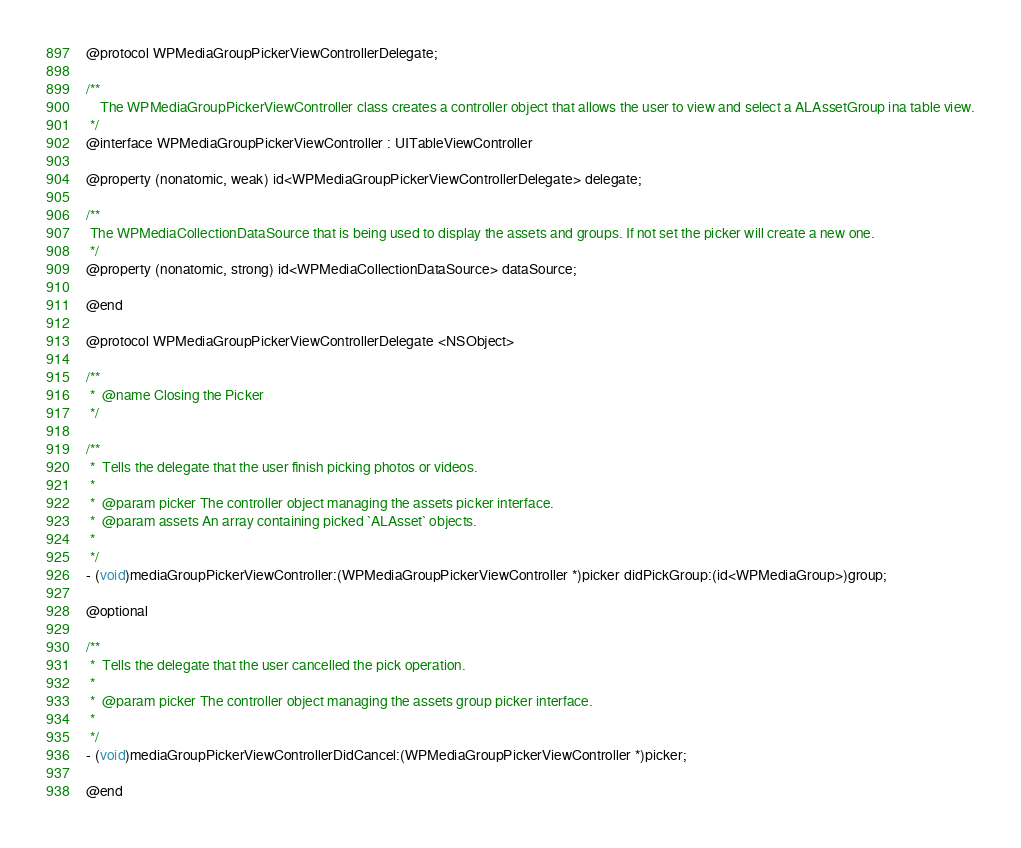<code> <loc_0><loc_0><loc_500><loc_500><_C_>
@protocol WPMediaGroupPickerViewControllerDelegate;

/**
    The WPMediaGroupPickerViewController class creates a controller object that allows the user to view and select a ALAssetGroup ina table view.
 */
@interface WPMediaGroupPickerViewController : UITableViewController

@property (nonatomic, weak) id<WPMediaGroupPickerViewControllerDelegate> delegate;

/**
 The WPMediaCollectionDataSource that is being used to display the assets and groups. If not set the picker will create a new one.
 */
@property (nonatomic, strong) id<WPMediaCollectionDataSource> dataSource;

@end

@protocol WPMediaGroupPickerViewControllerDelegate <NSObject>

/**
 *  @name Closing the Picker
 */

/**
 *  Tells the delegate that the user finish picking photos or videos.
 *
 *  @param picker The controller object managing the assets picker interface.
 *  @param assets An array containing picked `ALAsset` objects.
 *
 */
- (void)mediaGroupPickerViewController:(WPMediaGroupPickerViewController *)picker didPickGroup:(id<WPMediaGroup>)group;

@optional

/**
 *  Tells the delegate that the user cancelled the pick operation.
 *
 *  @param picker The controller object managing the assets group picker interface.
 *
 */
- (void)mediaGroupPickerViewControllerDidCancel:(WPMediaGroupPickerViewController *)picker;

@end</code> 